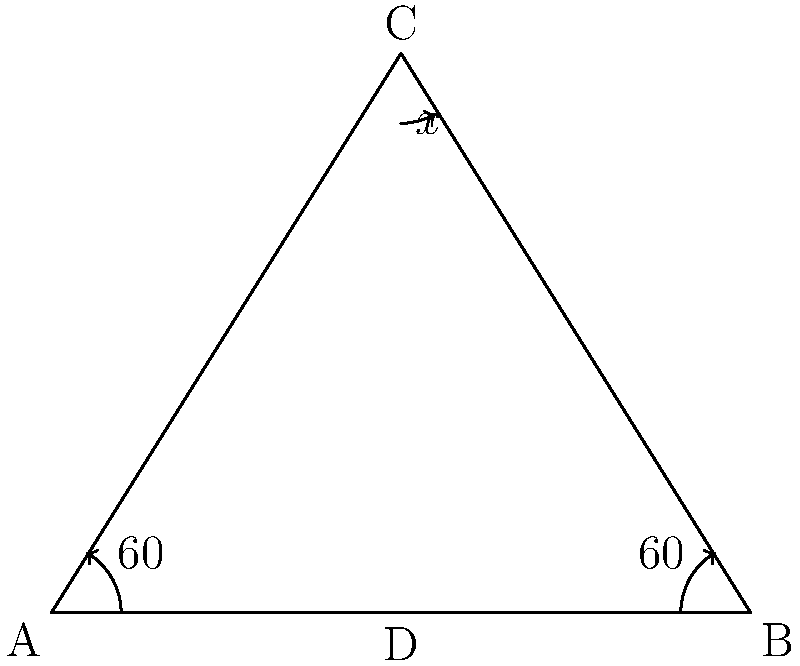At the Oakwell Stadium in Barnsley, you notice that the crossbar and goalposts of the football goal form an isosceles triangle. The angles at the base of this triangle are both $60°$. What is the value of the angle $x$ at the top of the goalpost? Let's approach this step-by-step:

1) First, recall that in an isosceles triangle, the angles opposite the equal sides are equal. Here, we're told that the base angles are both $60°$.

2) In any triangle, we know that the sum of all internal angles is always $180°$.

3) Let's call the angle at the top of the goalpost $x°$.

4) We can now set up an equation:
   $60° + 60° + x° = 180°$

5) Simplifying:
   $120° + x° = 180°$

6) Subtracting $120°$ from both sides:
   $x° = 180° - 120° = 60°$

Therefore, the angle $x$ at the top of the goalpost is $60°$.

This forms an equilateral triangle, where all sides and all angles are equal - just like the perfect symmetry you'd want in a well-constructed football goal!
Answer: $60°$ 